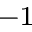Convert formula to latex. <formula><loc_0><loc_0><loc_500><loc_500>^ { - 1 }</formula> 